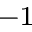Convert formula to latex. <formula><loc_0><loc_0><loc_500><loc_500>^ { - 1 }</formula> 